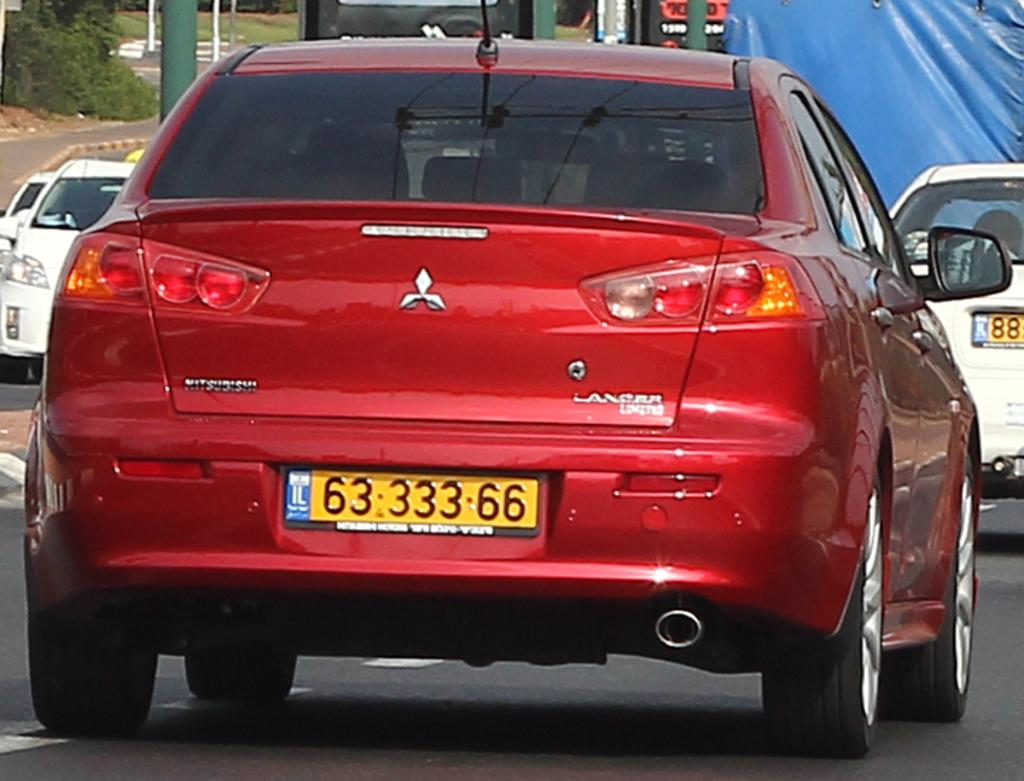<image>
Present a compact description of the photo's key features. A red Mitsubishi car with a license plate of 6333366. 